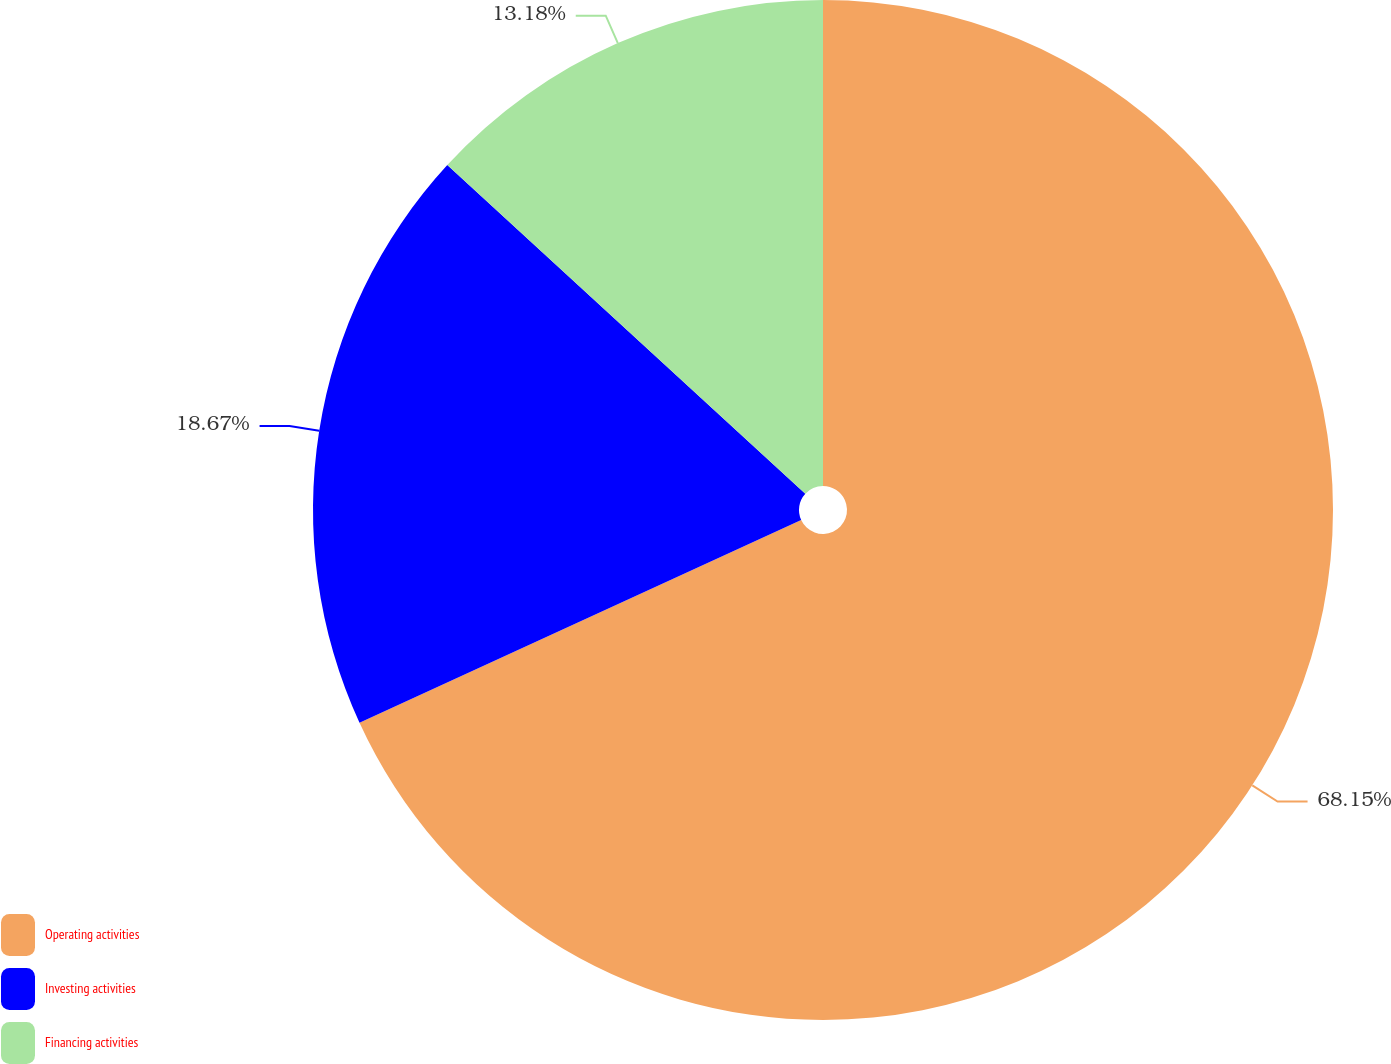Convert chart to OTSL. <chart><loc_0><loc_0><loc_500><loc_500><pie_chart><fcel>Operating activities<fcel>Investing activities<fcel>Financing activities<nl><fcel>68.15%<fcel>18.67%<fcel>13.18%<nl></chart> 